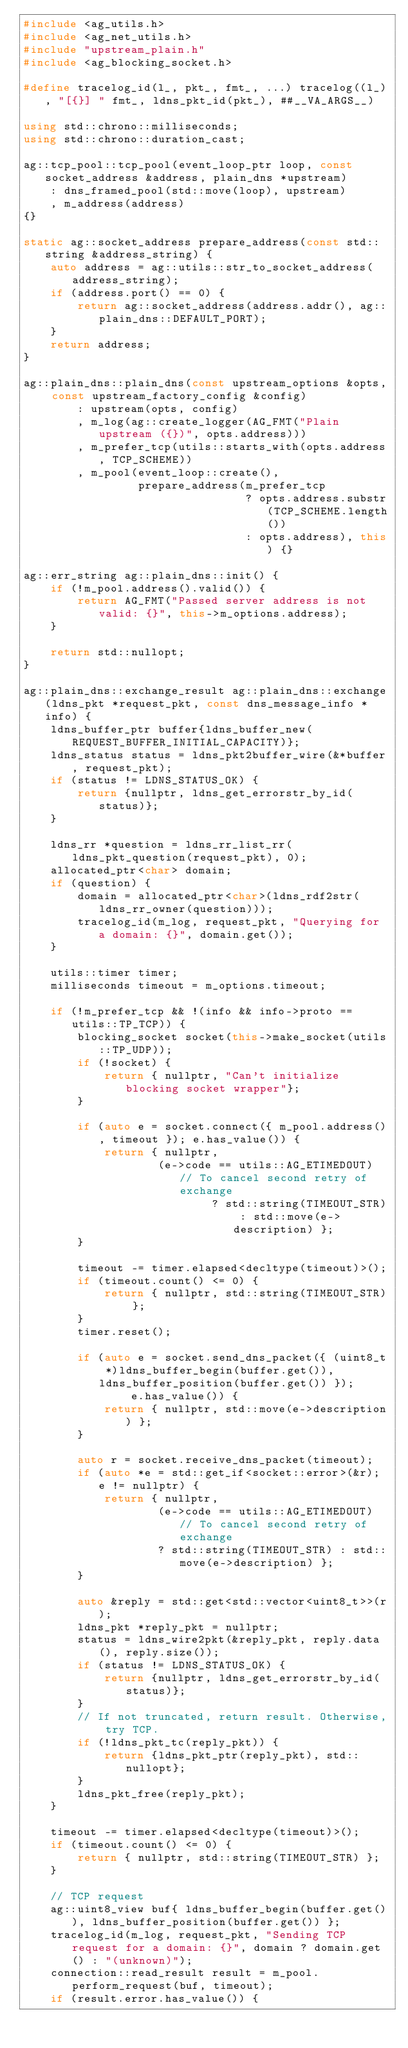Convert code to text. <code><loc_0><loc_0><loc_500><loc_500><_C++_>#include <ag_utils.h>
#include <ag_net_utils.h>
#include "upstream_plain.h"
#include <ag_blocking_socket.h>

#define tracelog_id(l_, pkt_, fmt_, ...) tracelog((l_), "[{}] " fmt_, ldns_pkt_id(pkt_), ##__VA_ARGS__)

using std::chrono::milliseconds;
using std::chrono::duration_cast;

ag::tcp_pool::tcp_pool(event_loop_ptr loop, const socket_address &address, plain_dns *upstream)
    : dns_framed_pool(std::move(loop), upstream)
    , m_address(address)
{}

static ag::socket_address prepare_address(const std::string &address_string) {
    auto address = ag::utils::str_to_socket_address(address_string);
    if (address.port() == 0) {
        return ag::socket_address(address.addr(), ag::plain_dns::DEFAULT_PORT);
    }
    return address;
}

ag::plain_dns::plain_dns(const upstream_options &opts, const upstream_factory_config &config)
        : upstream(opts, config)
        , m_log(ag::create_logger(AG_FMT("Plain upstream ({})", opts.address)))
        , m_prefer_tcp(utils::starts_with(opts.address, TCP_SCHEME))
        , m_pool(event_loop::create(),
                 prepare_address(m_prefer_tcp
                                 ? opts.address.substr(TCP_SCHEME.length())
                                 : opts.address), this) {}

ag::err_string ag::plain_dns::init() {
    if (!m_pool.address().valid()) {
        return AG_FMT("Passed server address is not valid: {}", this->m_options.address);
    }

    return std::nullopt;
}

ag::plain_dns::exchange_result ag::plain_dns::exchange(ldns_pkt *request_pkt, const dns_message_info *info) {
    ldns_buffer_ptr buffer{ldns_buffer_new(REQUEST_BUFFER_INITIAL_CAPACITY)};
    ldns_status status = ldns_pkt2buffer_wire(&*buffer, request_pkt);
    if (status != LDNS_STATUS_OK) {
        return {nullptr, ldns_get_errorstr_by_id(status)};
    }

    ldns_rr *question = ldns_rr_list_rr(ldns_pkt_question(request_pkt), 0);
    allocated_ptr<char> domain;
    if (question) {
        domain = allocated_ptr<char>(ldns_rdf2str(ldns_rr_owner(question)));
        tracelog_id(m_log, request_pkt, "Querying for a domain: {}", domain.get());
    }

    utils::timer timer;
    milliseconds timeout = m_options.timeout;

    if (!m_prefer_tcp && !(info && info->proto == utils::TP_TCP)) {
        blocking_socket socket(this->make_socket(utils::TP_UDP));
        if (!socket) {
            return { nullptr, "Can't initialize blocking socket wrapper"};
        }

        if (auto e = socket.connect({ m_pool.address(), timeout }); e.has_value()) {
            return { nullptr,
                    (e->code == utils::AG_ETIMEDOUT) // To cancel second retry of exchange
                            ? std::string(TIMEOUT_STR) : std::move(e->description) };
        }

        timeout -= timer.elapsed<decltype(timeout)>();
        if (timeout.count() <= 0) {
            return { nullptr, std::string(TIMEOUT_STR) };
        }
        timer.reset();

        if (auto e = socket.send_dns_packet({ (uint8_t *)ldns_buffer_begin(buffer.get()), ldns_buffer_position(buffer.get()) });
                e.has_value()) {
            return { nullptr, std::move(e->description) };
        }

        auto r = socket.receive_dns_packet(timeout);
        if (auto *e = std::get_if<socket::error>(&r); e != nullptr) {
            return { nullptr,
                    (e->code == utils::AG_ETIMEDOUT) // To cancel second retry of exchange
                    ? std::string(TIMEOUT_STR) : std::move(e->description) };
        }

        auto &reply = std::get<std::vector<uint8_t>>(r);
        ldns_pkt *reply_pkt = nullptr;
        status = ldns_wire2pkt(&reply_pkt, reply.data(), reply.size());
        if (status != LDNS_STATUS_OK) {
            return {nullptr, ldns_get_errorstr_by_id(status)};
        }
        // If not truncated, return result. Otherwise, try TCP.
        if (!ldns_pkt_tc(reply_pkt)) {
            return {ldns_pkt_ptr(reply_pkt), std::nullopt};
        }
        ldns_pkt_free(reply_pkt);
    }

    timeout -= timer.elapsed<decltype(timeout)>();
    if (timeout.count() <= 0) {
        return { nullptr, std::string(TIMEOUT_STR) };
    }

    // TCP request
    ag::uint8_view buf{ ldns_buffer_begin(buffer.get()), ldns_buffer_position(buffer.get()) };
    tracelog_id(m_log, request_pkt, "Sending TCP request for a domain: {}", domain ? domain.get() : "(unknown)");
    connection::read_result result = m_pool.perform_request(buf, timeout);
    if (result.error.has_value()) {</code> 